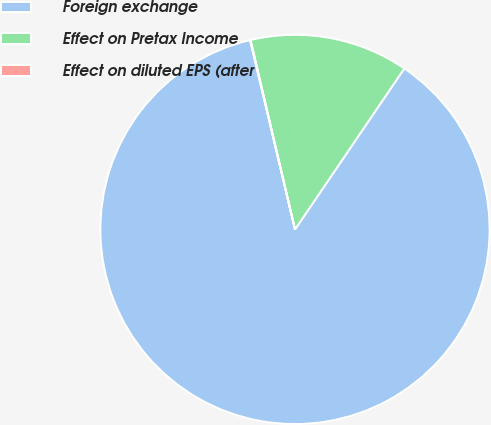<chart> <loc_0><loc_0><loc_500><loc_500><pie_chart><fcel>Foreign exchange<fcel>Effect on Pretax Income<fcel>Effect on diluted EPS (after<nl><fcel>86.8%<fcel>13.16%<fcel>0.04%<nl></chart> 